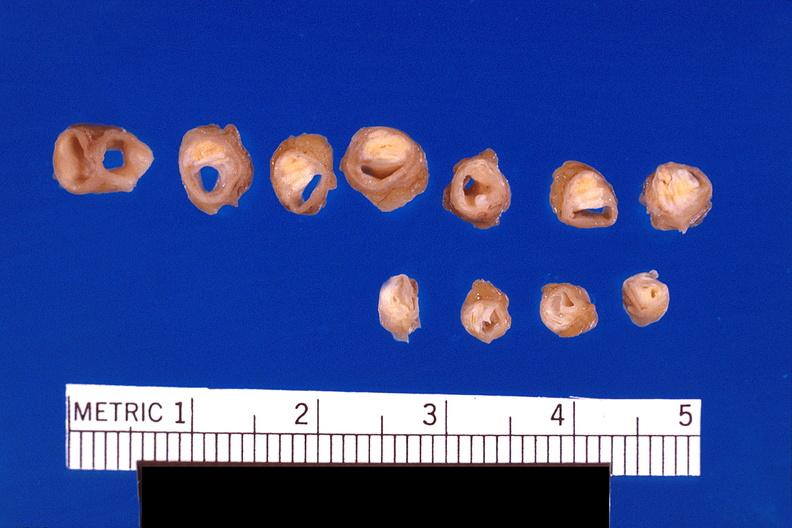what does this image show?
Answer the question using a single word or phrase. Atherosclerosis 